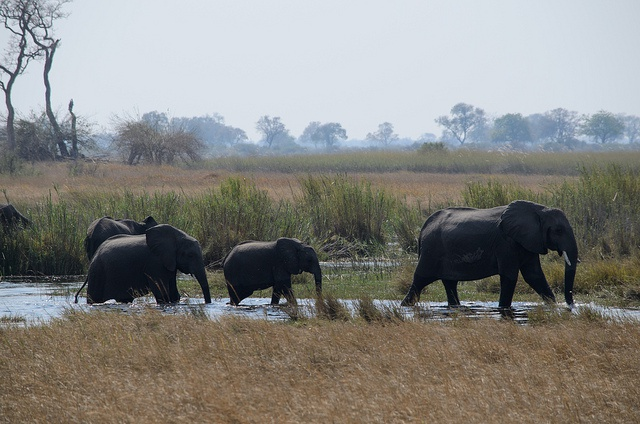Describe the objects in this image and their specific colors. I can see elephant in darkgray, black, gray, and darkgreen tones, elephant in darkgray, black, and gray tones, elephant in darkgray, black, gray, and darkgreen tones, elephant in darkgray, black, and gray tones, and elephant in darkgray, black, gray, and darkgreen tones in this image. 